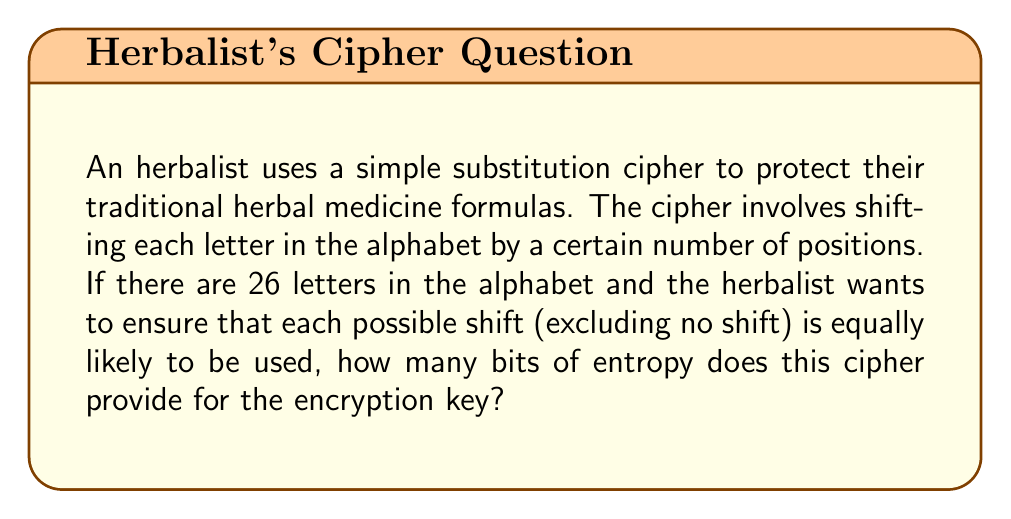Can you answer this question? To solve this problem, we need to follow these steps:

1. Determine the number of possible keys:
   - There are 26 letters in the alphabet.
   - We exclude the case of no shift (0 positions).
   - So, there are 25 possible shifts (1 to 25).

2. Calculate the entropy:
   - Entropy is measured in bits and is calculated using the formula:
     $$ H = \log_2(n) $$
   where $n$ is the number of equally likely possibilities.

3. Apply the formula:
   $$ H = \log_2(25) $$

4. Calculate the result:
   $$ H \approx 4.64385619 \text{ bits} $$

5. Round to two decimal places:
   $$ H \approx 4.64 \text{ bits} $$

This means that the encryption key for this simple substitution cipher provides approximately 4.64 bits of entropy.
Answer: 4.64 bits 